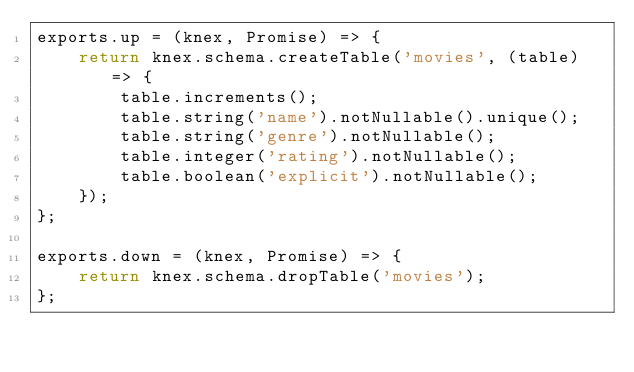Convert code to text. <code><loc_0><loc_0><loc_500><loc_500><_JavaScript_>exports.up = (knex, Promise) => {
    return knex.schema.createTable('movies', (table) => {
        table.increments();
        table.string('name').notNullable().unique();
        table.string('genre').notNullable();
        table.integer('rating').notNullable();
        table.boolean('explicit').notNullable();
    });
};

exports.down = (knex, Promise) => {
    return knex.schema.dropTable('movies');
};
</code> 